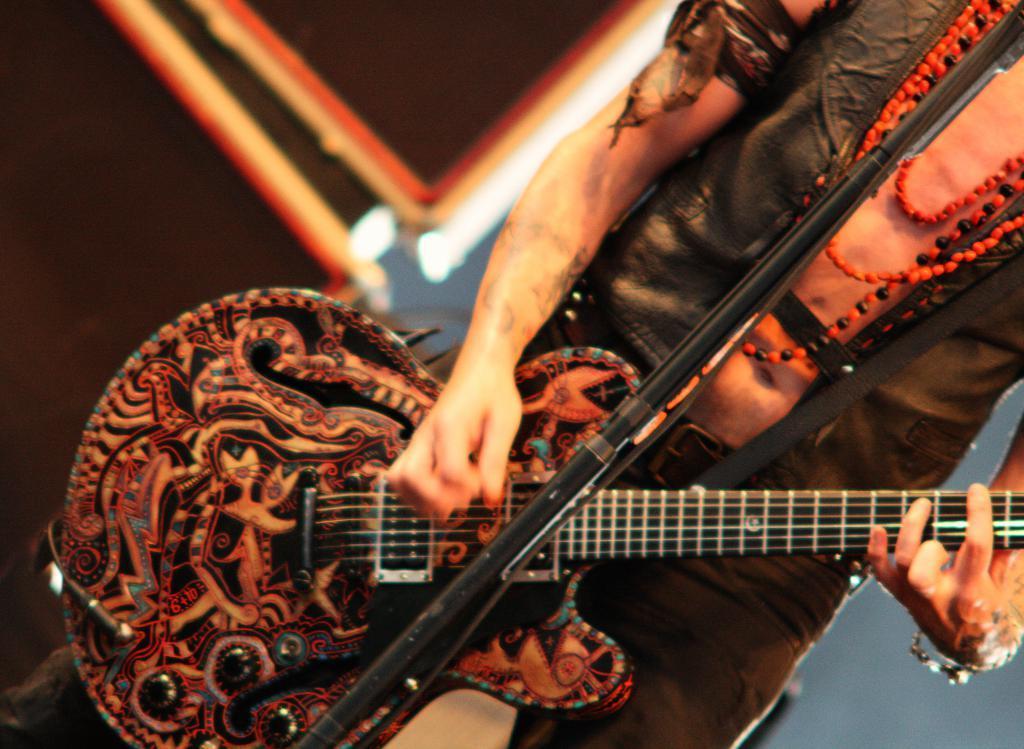In one or two sentences, can you explain what this image depicts? In this image we can see a person playing a guitar and there is a mic stand in front of the person, there are speakers beside the person and a white background. 